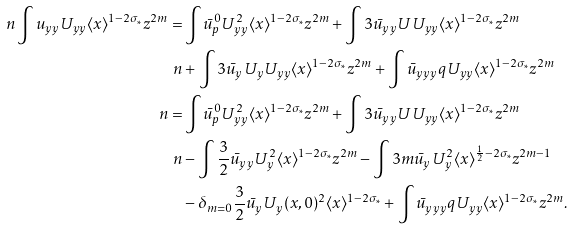Convert formula to latex. <formula><loc_0><loc_0><loc_500><loc_500>\ n \int u _ { y y } U _ { y y } \langle x \rangle ^ { 1 - 2 \sigma _ { \ast } } z ^ { 2 m } = & \int \bar { u } ^ { 0 } _ { p } U _ { y y } ^ { 2 } \langle x \rangle ^ { 1 - 2 \sigma _ { \ast } } z ^ { 2 m } + \int 3 \bar { u } _ { y y } U U _ { y y } \langle x \rangle ^ { 1 - 2 \sigma _ { \ast } } z ^ { 2 m } \\ \ n & + \int 3 \bar { u } _ { y } U _ { y } U _ { y y } \langle x \rangle ^ { 1 - 2 \sigma _ { \ast } } z ^ { 2 m } + \int \bar { u } _ { y y y } q U _ { y y } \langle x \rangle ^ { 1 - 2 \sigma _ { \ast } } z ^ { 2 m } \\ \ n = & \int \bar { u } ^ { 0 } _ { p } U _ { y y } ^ { 2 } \langle x \rangle ^ { 1 - 2 \sigma _ { \ast } } z ^ { 2 m } + \int 3 \bar { u } _ { y y } U U _ { y y } \langle x \rangle ^ { 1 - 2 \sigma _ { \ast } } z ^ { 2 m } \\ \ n & - \int \frac { 3 } { 2 } \bar { u } _ { y y } U _ { y } ^ { 2 } \langle x \rangle ^ { 1 - 2 \sigma _ { \ast } } z ^ { 2 m } - \int 3 m \bar { u } _ { y } U _ { y } ^ { 2 } \langle x \rangle ^ { \frac { 1 } { 2 } - 2 \sigma _ { \ast } } z ^ { 2 m - 1 } \\ & - \delta _ { m = 0 } \frac { 3 } { 2 } \bar { u } _ { y } U _ { y } ( x , 0 ) ^ { 2 } \langle x \rangle ^ { 1 - 2 \sigma _ { \ast } } + \int \bar { u } _ { y y y } q U _ { y y } \langle x \rangle ^ { 1 - 2 \sigma _ { \ast } } z ^ { 2 m } .</formula> 